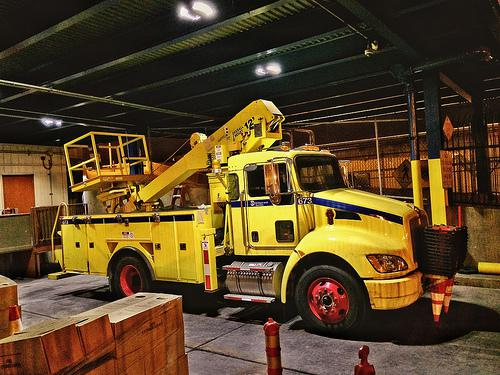Question: what color is it?
Choices:
A. Blue.
B. Green.
C. Red.
D. Yellow.
Answer with the letter. Answer: D Question: who is present?
Choices:
A. Policemen.
B. Nobody.
C. Children.
D. Pastors.
Answer with the letter. Answer: B Question: when was this?
Choices:
A. Morning.
B. Afternoon.
C. Nighttime.
D. Evening.
Answer with the letter. Answer: C Question: where was this photo taken?
Choices:
A. In a parking garage for this vehicle.
B. At a party.
C. At the bank.
D. In a river.
Answer with the letter. Answer: A Question: what color is the ground?
Choices:
A. Black.
B. Green.
C. Grey.
D. Yellow.
Answer with the letter. Answer: C 